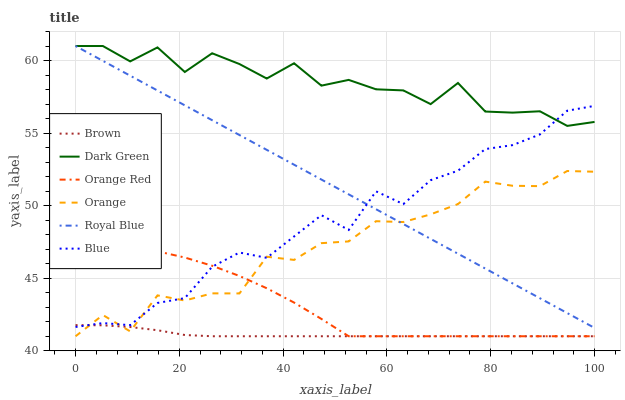Does Brown have the minimum area under the curve?
Answer yes or no. Yes. Does Dark Green have the maximum area under the curve?
Answer yes or no. Yes. Does Royal Blue have the minimum area under the curve?
Answer yes or no. No. Does Royal Blue have the maximum area under the curve?
Answer yes or no. No. Is Royal Blue the smoothest?
Answer yes or no. Yes. Is Dark Green the roughest?
Answer yes or no. Yes. Is Brown the smoothest?
Answer yes or no. No. Is Brown the roughest?
Answer yes or no. No. Does Brown have the lowest value?
Answer yes or no. Yes. Does Royal Blue have the lowest value?
Answer yes or no. No. Does Dark Green have the highest value?
Answer yes or no. Yes. Does Brown have the highest value?
Answer yes or no. No. Is Orange Red less than Royal Blue?
Answer yes or no. Yes. Is Dark Green greater than Orange?
Answer yes or no. Yes. Does Orange intersect Royal Blue?
Answer yes or no. Yes. Is Orange less than Royal Blue?
Answer yes or no. No. Is Orange greater than Royal Blue?
Answer yes or no. No. Does Orange Red intersect Royal Blue?
Answer yes or no. No. 